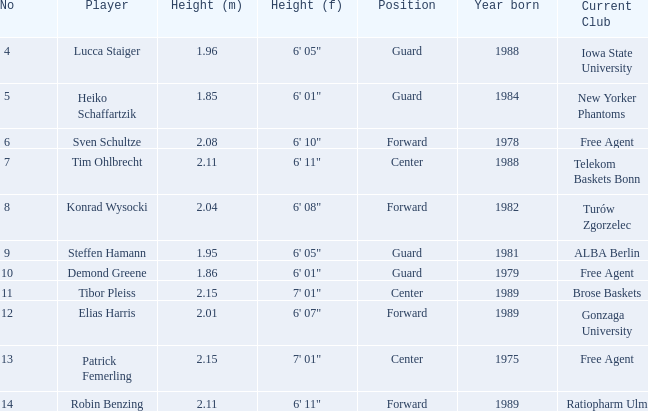Which competitor stands at Heiko Schaffartzik. 